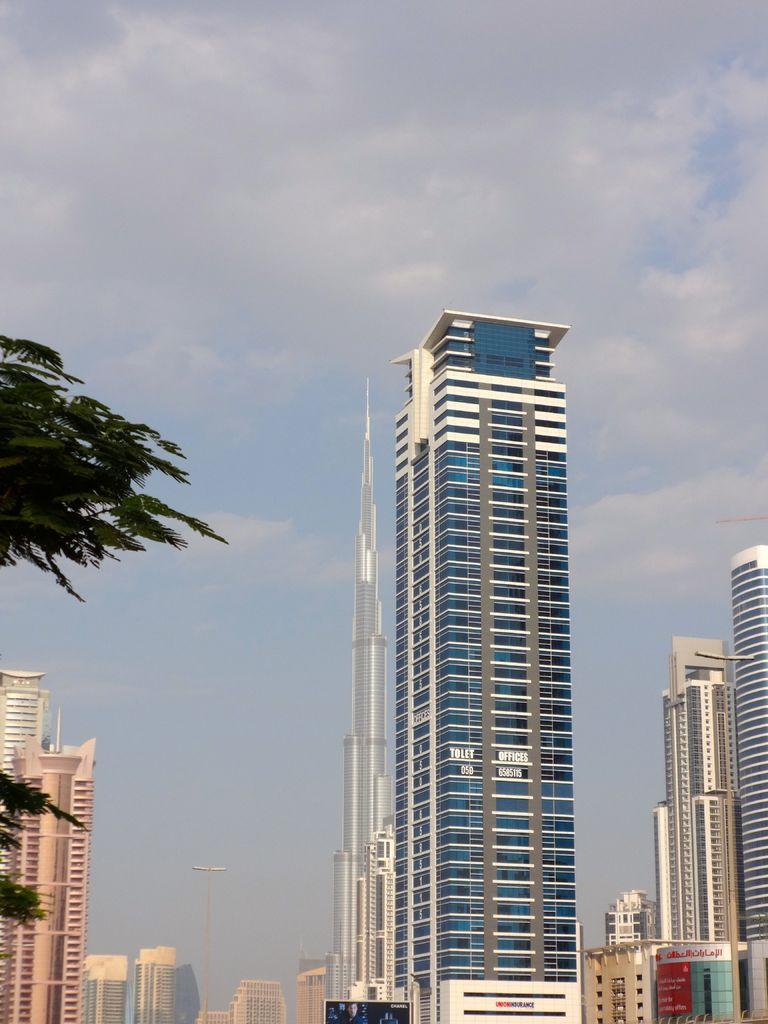Describe this image in one or two sentences. In this image there are some buildings and skyscrapers and some poles, on the left side there is a tree. At the top of the image there is sky. 